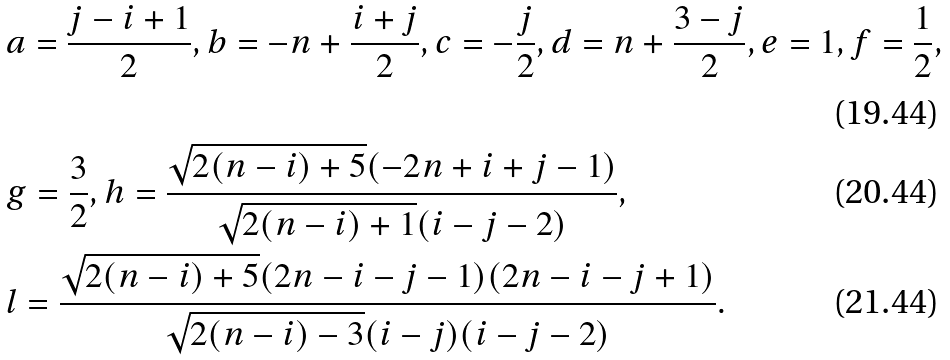<formula> <loc_0><loc_0><loc_500><loc_500>& a = \frac { j - i + 1 } { 2 } , b = - n + \frac { i + j } { 2 } , c = - \frac { j } { 2 } , d = n + \frac { 3 - j } { 2 } , e = 1 , f = \frac { 1 } { 2 } , \\ & g = \frac { 3 } { 2 } , h = \frac { \sqrt { 2 ( n - i ) + 5 } ( - 2 n + i + j - 1 ) } { \sqrt { 2 ( n - i ) + 1 } ( i - j - 2 ) } , \\ & l = \frac { \sqrt { 2 ( n - i ) + 5 } ( 2 n - i - j - 1 ) ( 2 n - i - j + 1 ) } { \sqrt { 2 ( n - i ) - 3 } ( i - j ) ( i - j - 2 ) } .</formula> 